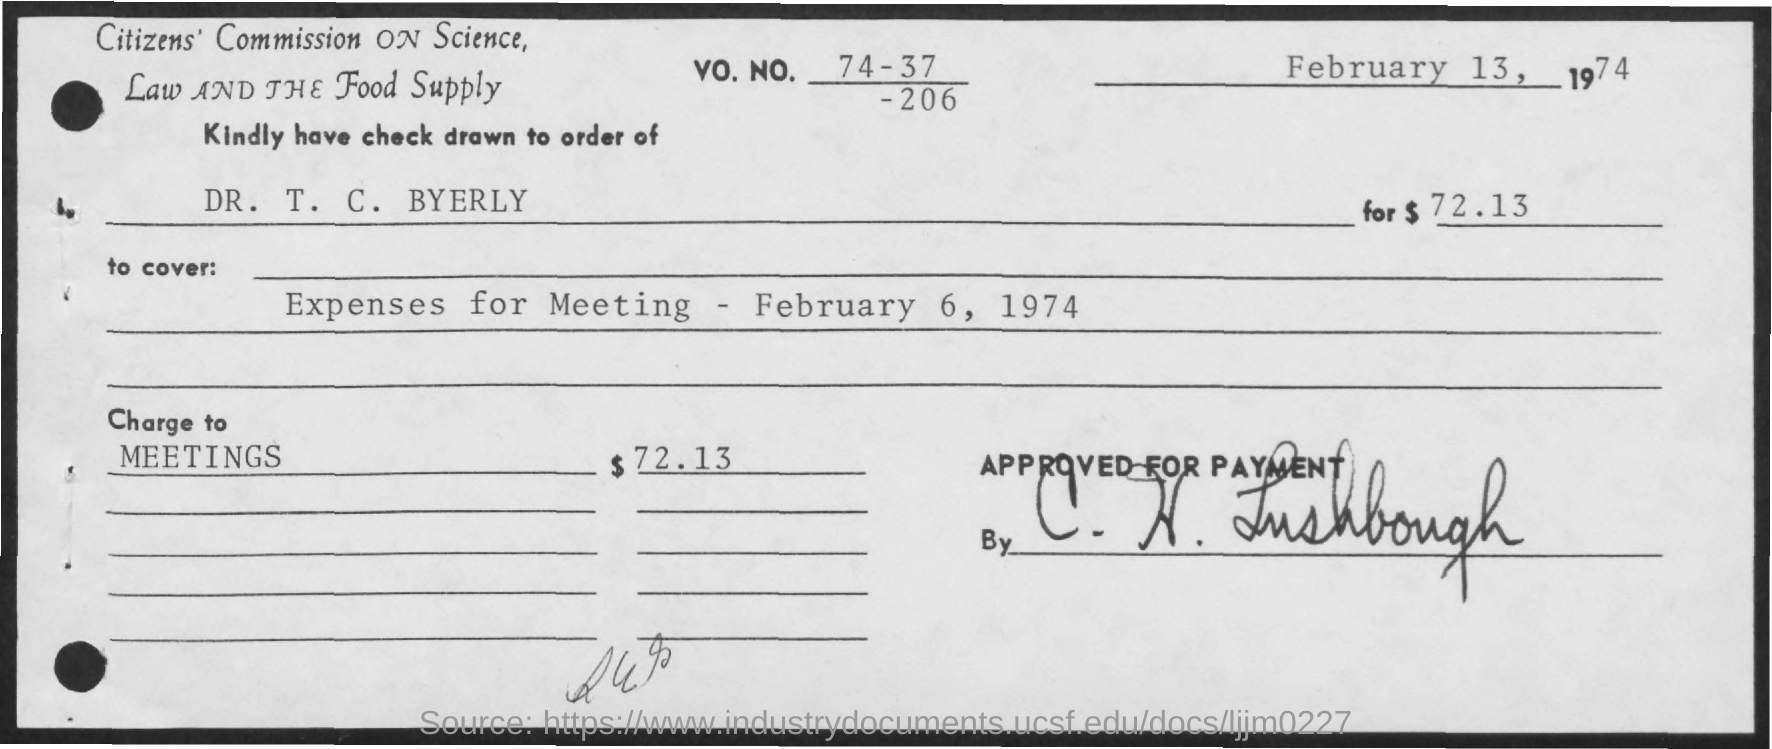What is the Vo. No. mentioned in the check?
Offer a terse response. 74-37-206. In whose name, the check is issued?
Offer a very short reply. DR. T. C. BYERLY. What is the check date ?
Provide a succinct answer. February 13. What is the amount of check?
Offer a terse response. $72.13. What charges are covered with the check given?
Your answer should be very brief. Expenses for Meeting - February 6, 1974. 